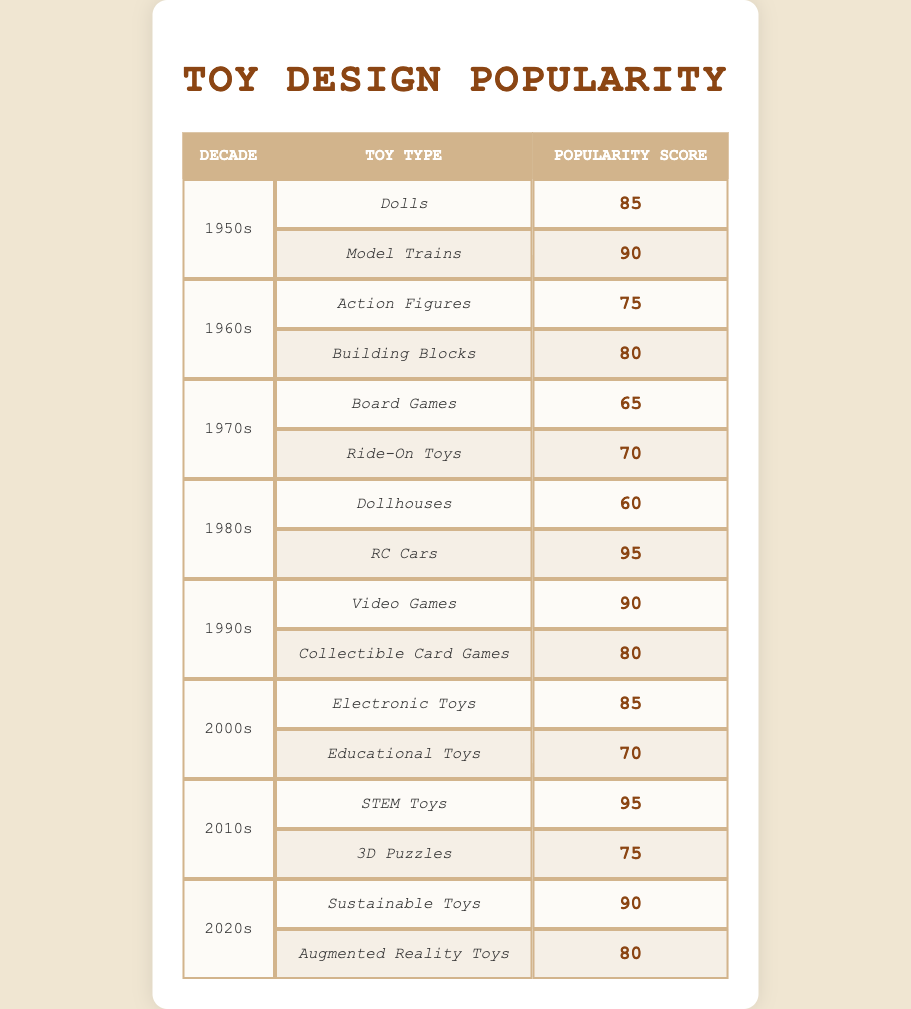What toy type had the highest popularity score in the 1980s? The table lists the toy types for the 1980s as Dollhouses (60) and RC Cars (95). Among these, RC Cars have the highest score of 95.
Answer: RC Cars Which decade had a higher average popularity score: the 1990s or the 2000s? For the 1990s, the scores are Video Games (90) and Collectible Card Games (80), giving an average of (90 + 80) / 2 = 85. For the 2000s, the scores are Electronic Toys (85) and Educational Toys (70), giving an average of (85 + 70) / 2 = 77.5. Comparing 85 and 77.5, the 1990s had the higher average.
Answer: 1990s Are there more toy types in the 1970s or 2000s? The table shows that the 1970s have Board Games and Ride-On Toys (2 types), while the 2000s have Electronic Toys and Educational Toys (also 2 types). Therefore, the number of toy types is the same.
Answer: No What is the difference between the highest and lowest popularity scores in the 1960s? In the 1960s, Action Figures have a score of 75 and Building Blocks have a score of 80. The highest score is 80 and the lowest score is 75. The difference is 80 - 75 = 5.
Answer: 5 Which decade saw the introduction of the highest popularity score toy type, and what was the score? The highest popularity score from all decades is 95 for RC Cars in the 1980s. Thus, the 1980s saw the introduction of this toy along with its highest score.
Answer: 1980s, 95 What was the popularity score for STEM Toys in the 2010s? The table specifically states that STEM Toys in the 2010s had a popularity score of 95. Therefore, the answer is clearly identified in the table.
Answer: 95 Did Model Trains have a higher popularity score than Video Games? The table shows that Model Trains scored 90 in the 1950s, while Video Games scored 90 in the 1990s. They have the same score of 90, so the answer is no; they are equal.
Answer: No What is the average popularity score for toys from the 2020s? In the 2020s, Sustainable Toys scored 90 and Augmented Reality Toys scored 80. To find the average, we calculate (90 + 80) / 2 = 85.
Answer: 85 